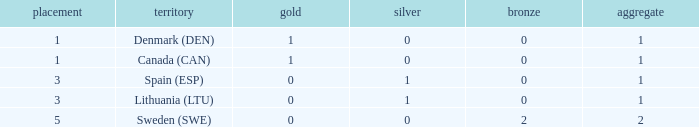Could you parse the entire table? {'header': ['placement', 'territory', 'gold', 'silver', 'bronze', 'aggregate'], 'rows': [['1', 'Denmark (DEN)', '1', '0', '0', '1'], ['1', 'Canada (CAN)', '1', '0', '0', '1'], ['3', 'Spain (ESP)', '0', '1', '0', '1'], ['3', 'Lithuania (LTU)', '0', '1', '0', '1'], ['5', 'Sweden (SWE)', '0', '0', '2', '2']]} What is the rank when there is 0 gold, the total is more than 1, and silver is more than 0? None. 